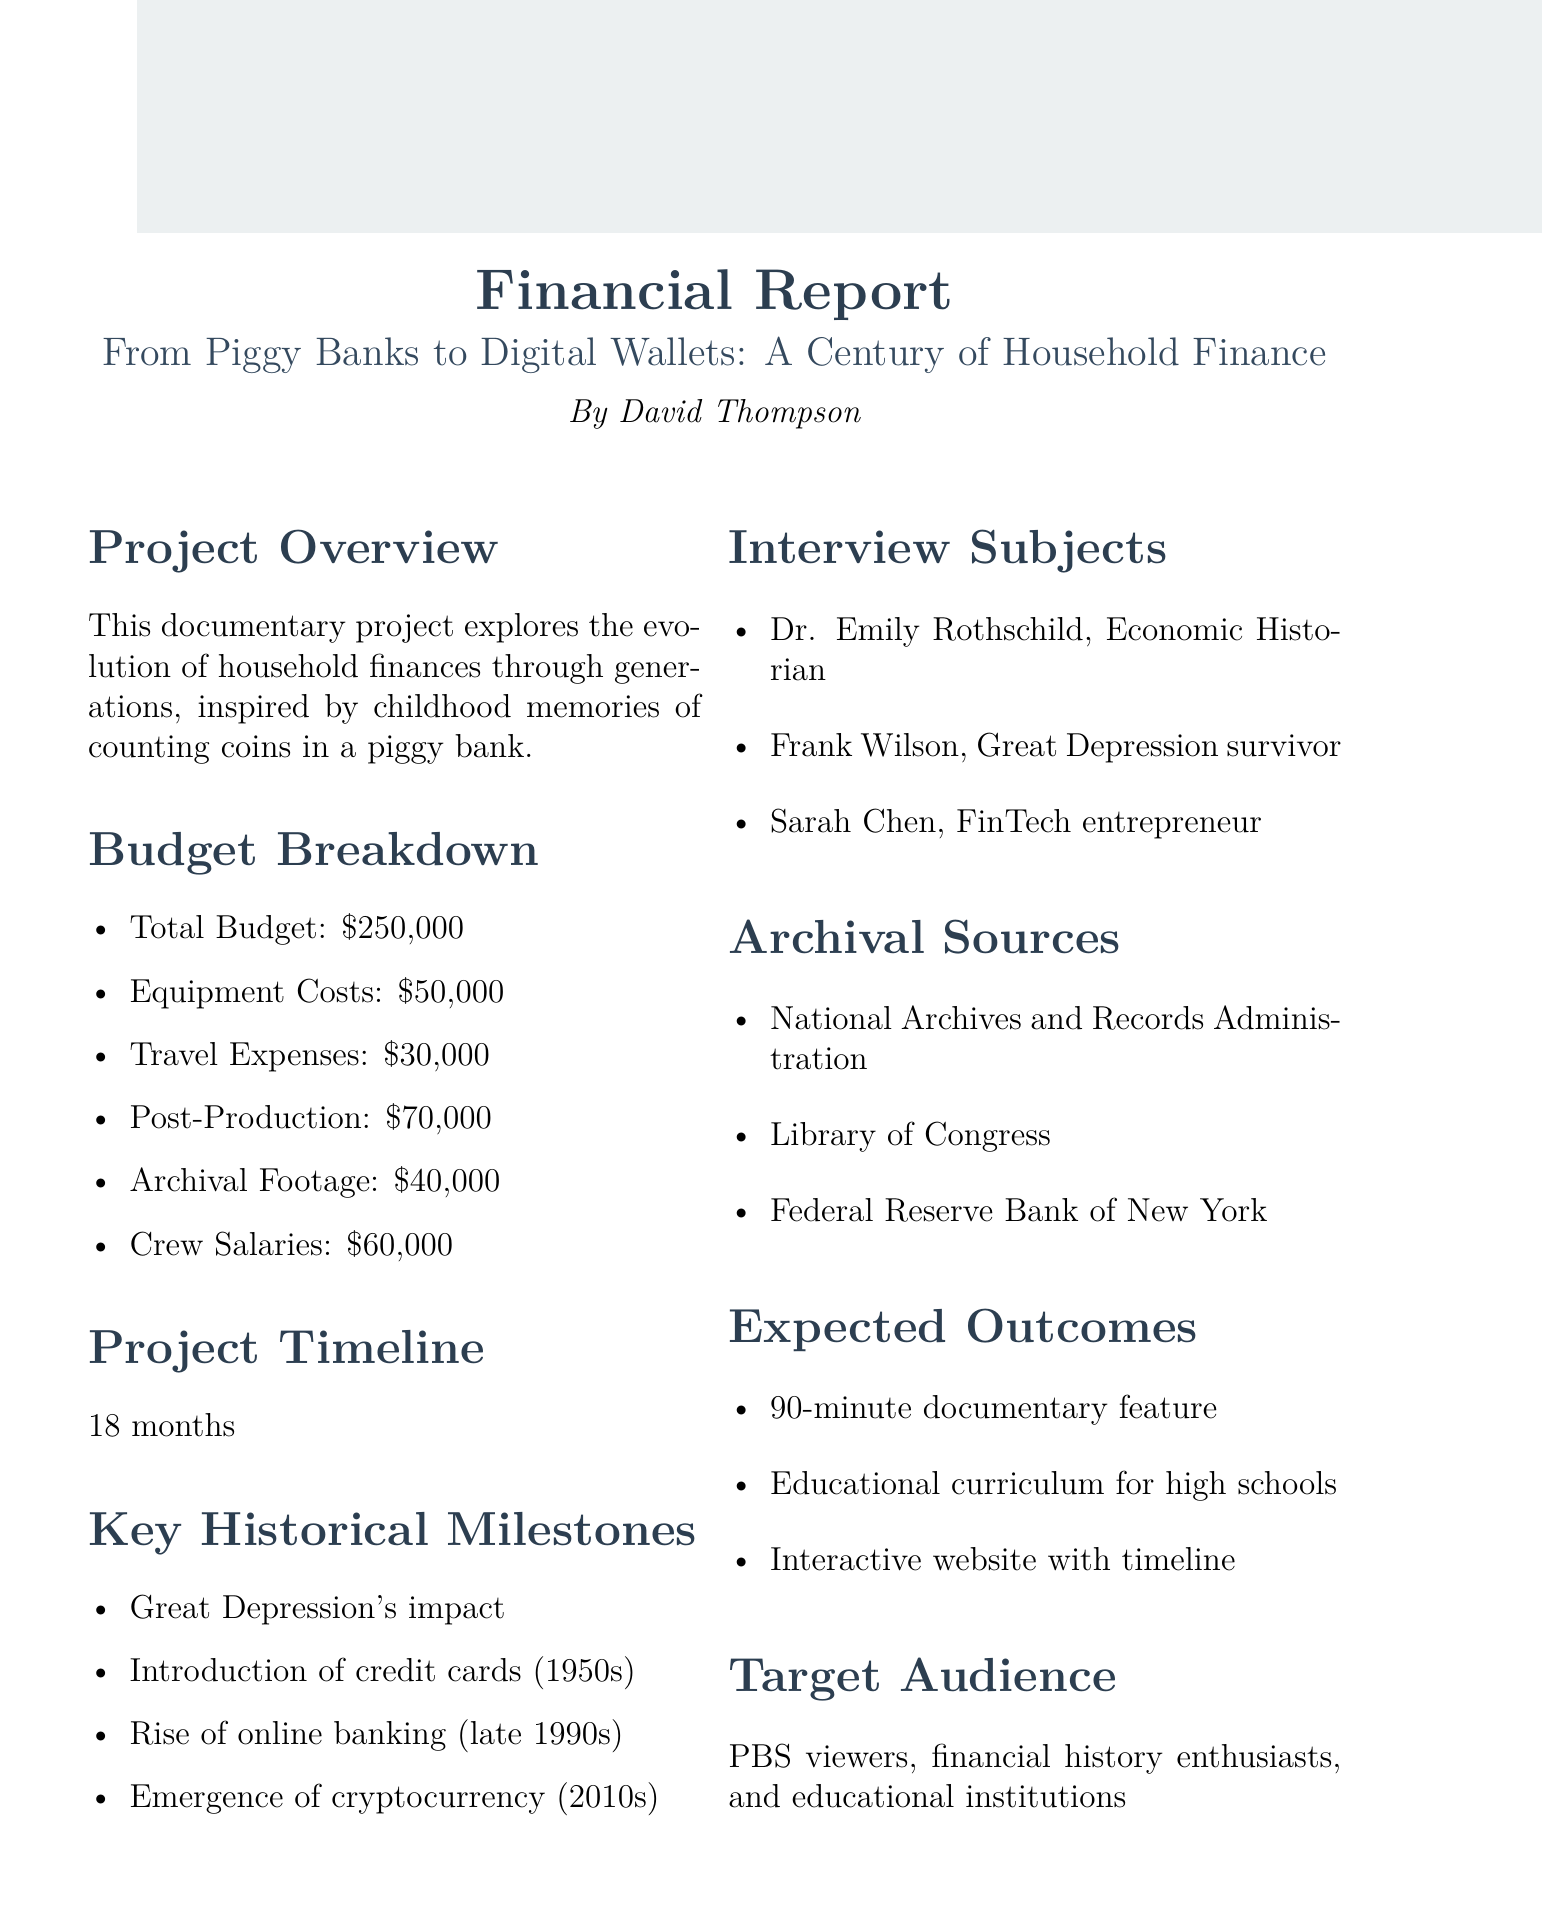what is the total budget? The total budget is listed as the primary funding requirement in the document, which is $250,000.
Answer: $250,000 what are the project timelines? The document specifies that the project timeline for the documentary is 18 months.
Answer: 18 months who is the filmmaker? The document identifies the filmmaker of the project as David Thompson.
Answer: David Thompson what is one of the key historical milestones mentioned? The document includes several historical milestones, such as the introduction of credit cards in the 1950s.
Answer: Introduction of credit cards in the 1950s how many interview subjects are listed? The document lists three interview subjects in the section regarding interview subjects.
Answer: Three what is the amount allocated for crew salaries? The budget breakdown indicates that crew salaries are set at $60,000.
Answer: $60,000 who is one of the archival sources? The document mentions the National Archives and Records Administration as one of the archival sources.
Answer: National Archives and Records Administration what is the expected outcome of the project? One of the expected outcomes is to create a 90-minute documentary feature.
Answer: 90-minute documentary feature who is one of the interview subjects? The document lists Dr. Emily Rothschild as one of the interview subjects.
Answer: Dr. Emily Rothschild 